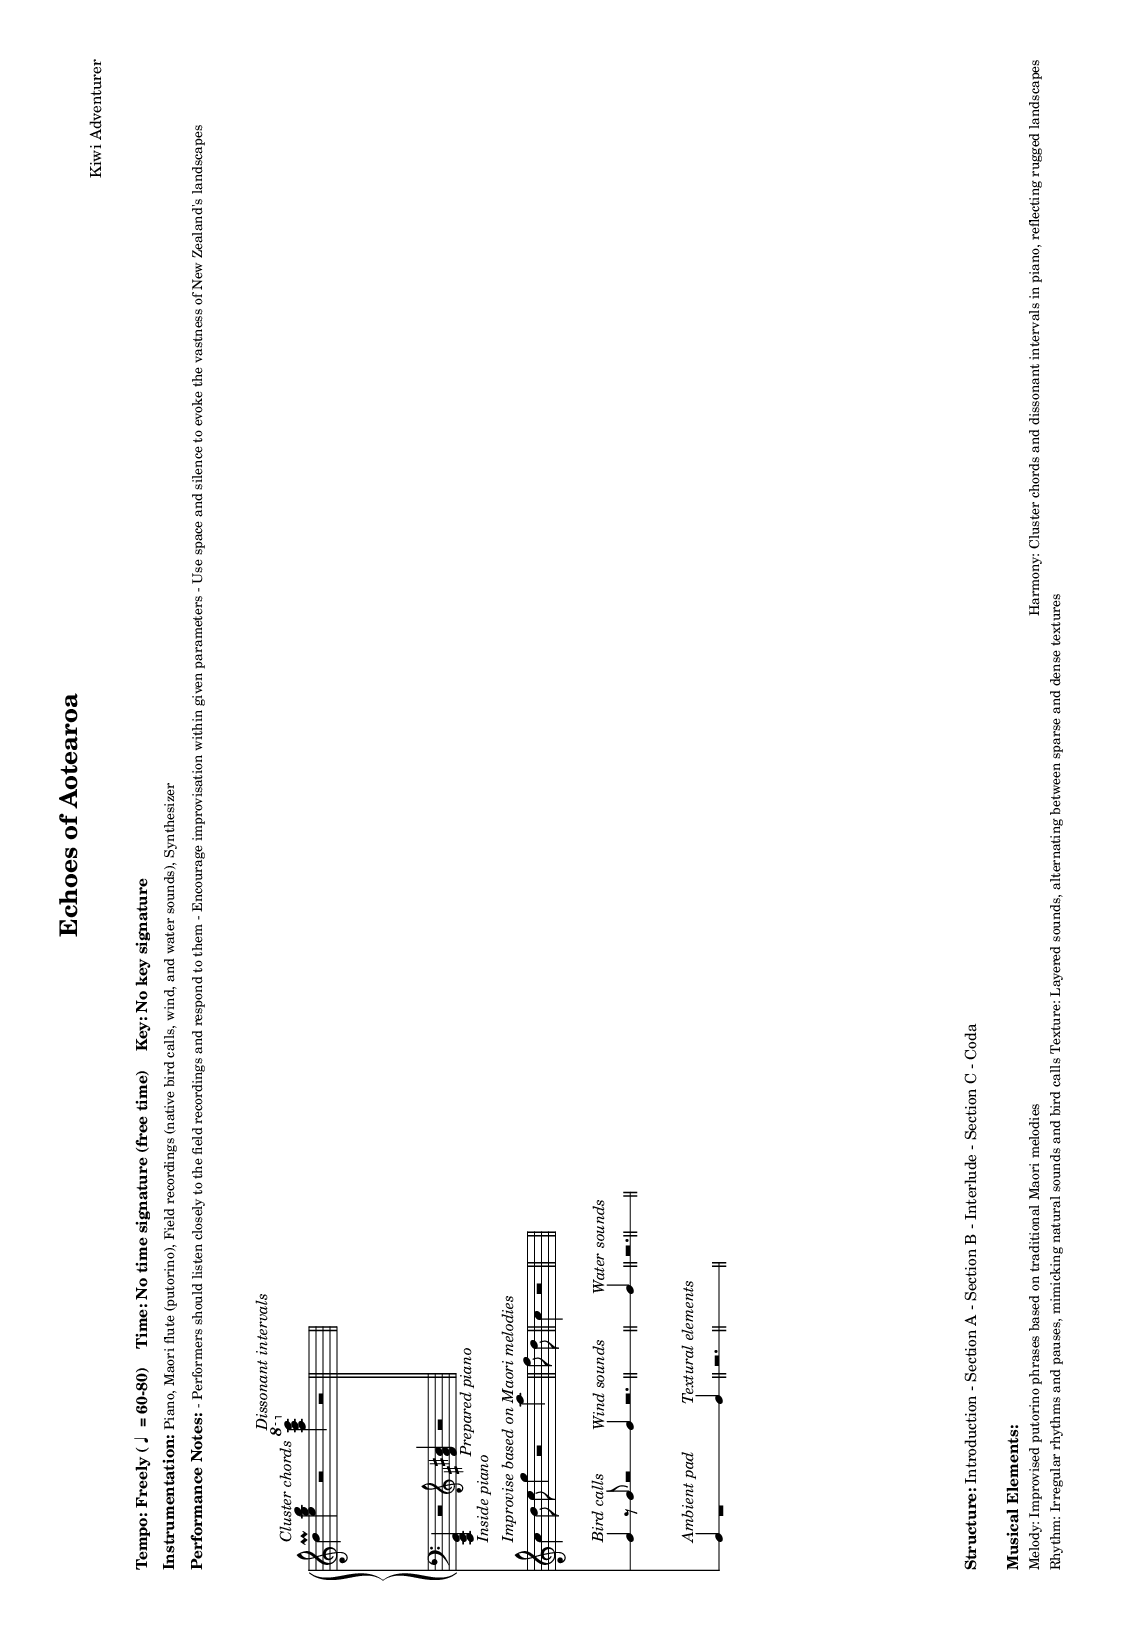What is the tempo of this music? The tempo indicated is "Freely" with a range specified as 60 to 80 beats per minute. This means the performers have flexibility in choosing the pace within that range.
Answer: Freely (60-80) What is the time signature of this piece? The score specifies "No time signature (free time)," indicating that the music does not adhere to a fixed meter, allowing for improvisation and freedom in timing.
Answer: No time signature What is the key signature of this composition? The piece has "No key signature," which means it is not in a traditional major or minor key and likely features a collection of pitches free from a tonal center.
Answer: No key signature What are the instruments used in this piece? The sheet music lists the instrumentation as piano, Maori flute (putorino), field recordings, and synthesizer. This provides a diverse range of sound sources.
Answer: Piano, Maori flute (putorino), Field recordings, Synthesizer How does the music structure itself? The structure is divided into sections: Introduction, Section A, Section B, Interlude, Section C, and Coda. This organization helps guide the performance and improvisation.
Answer: Introduction - Section A - Section B - Interlude - Section C - Coda What musical elements can be identified in this work? The score describes various elements: improvisation on the putorino, cluster chords in piano, irregular rhythms, and layered textures, reflecting the influence of New Zealand’s natural environment.
Answer: Melody, Harmony, Rhythm, Texture Why is improvisation emphasized in this music? The score encourages performers to respond to field recordings and explore improvisation, aligning with the experimental nature of the piece which aims to evoke the sounds of the natural landscape.
Answer: Performers should improvise 